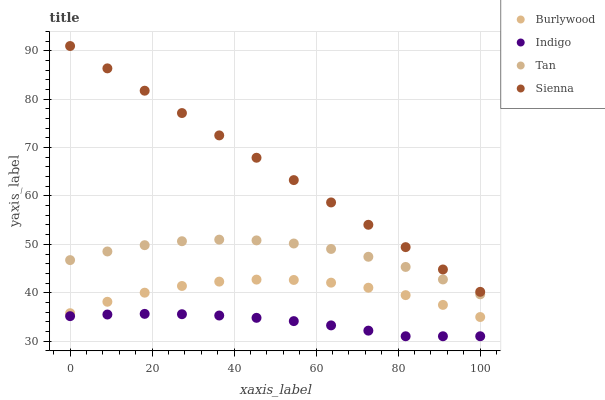Does Indigo have the minimum area under the curve?
Answer yes or no. Yes. Does Sienna have the maximum area under the curve?
Answer yes or no. Yes. Does Tan have the minimum area under the curve?
Answer yes or no. No. Does Tan have the maximum area under the curve?
Answer yes or no. No. Is Sienna the smoothest?
Answer yes or no. Yes. Is Burlywood the roughest?
Answer yes or no. Yes. Is Tan the smoothest?
Answer yes or no. No. Is Tan the roughest?
Answer yes or no. No. Does Indigo have the lowest value?
Answer yes or no. Yes. Does Tan have the lowest value?
Answer yes or no. No. Does Sienna have the highest value?
Answer yes or no. Yes. Does Tan have the highest value?
Answer yes or no. No. Is Indigo less than Burlywood?
Answer yes or no. Yes. Is Sienna greater than Tan?
Answer yes or no. Yes. Does Indigo intersect Burlywood?
Answer yes or no. No. 